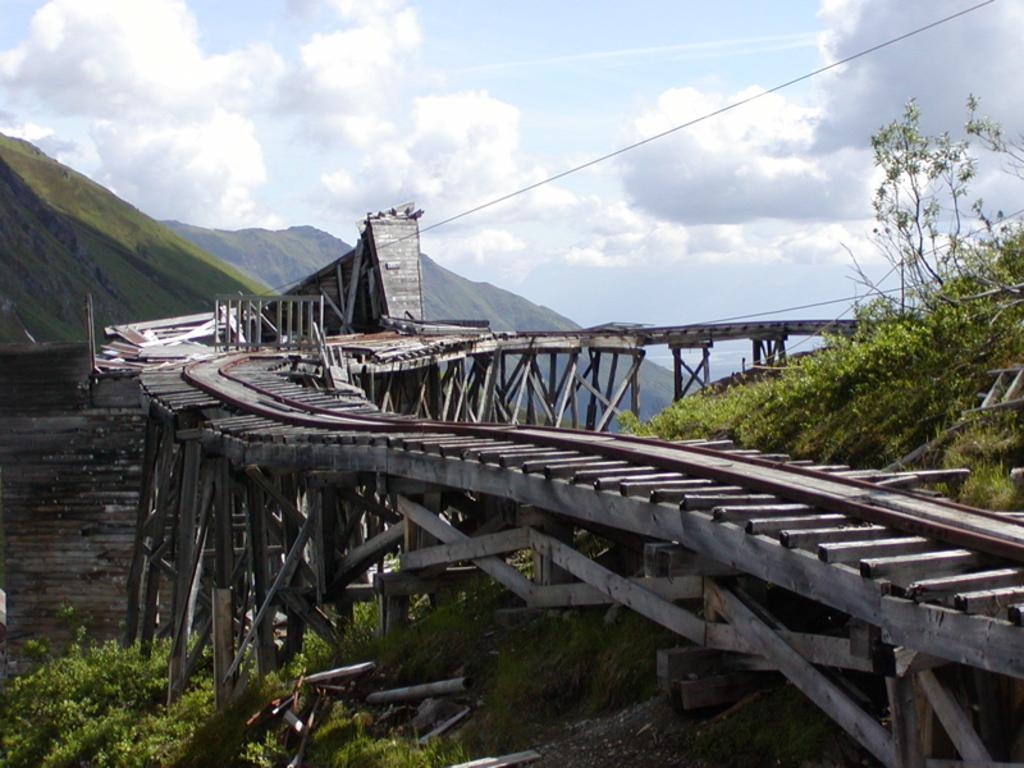What structure is visible in the image? There is a bridge in the image. What can be seen on the left side of the image? There are hills on the left side of the image. What type of vegetation is on the right side of the image? There are plants on the right side of the image. What is visible in the sky in the image? There are clouds in the sky. What type of songs can be heard playing from the bridge in the image? There is no indication in the image that songs are playing from the bridge, so it cannot be determined from the picture. 